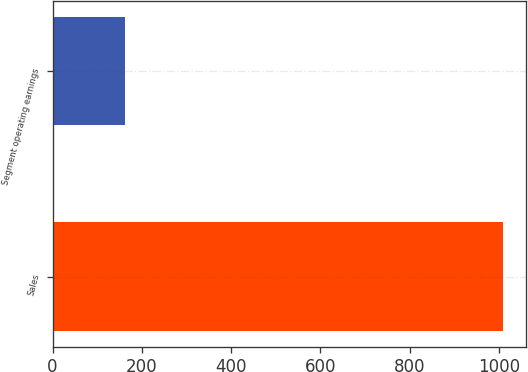Convert chart to OTSL. <chart><loc_0><loc_0><loc_500><loc_500><bar_chart><fcel>Sales<fcel>Segment operating earnings<nl><fcel>1010.1<fcel>162.6<nl></chart> 